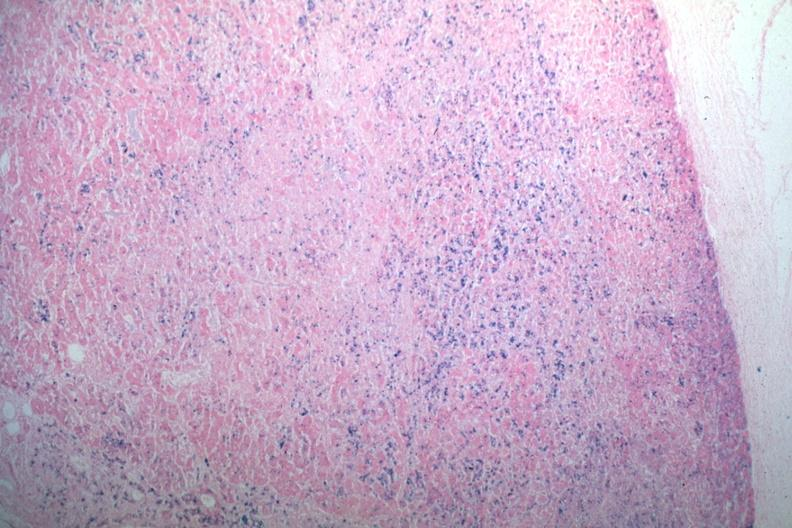s situs inversus present?
Answer the question using a single word or phrase. No 